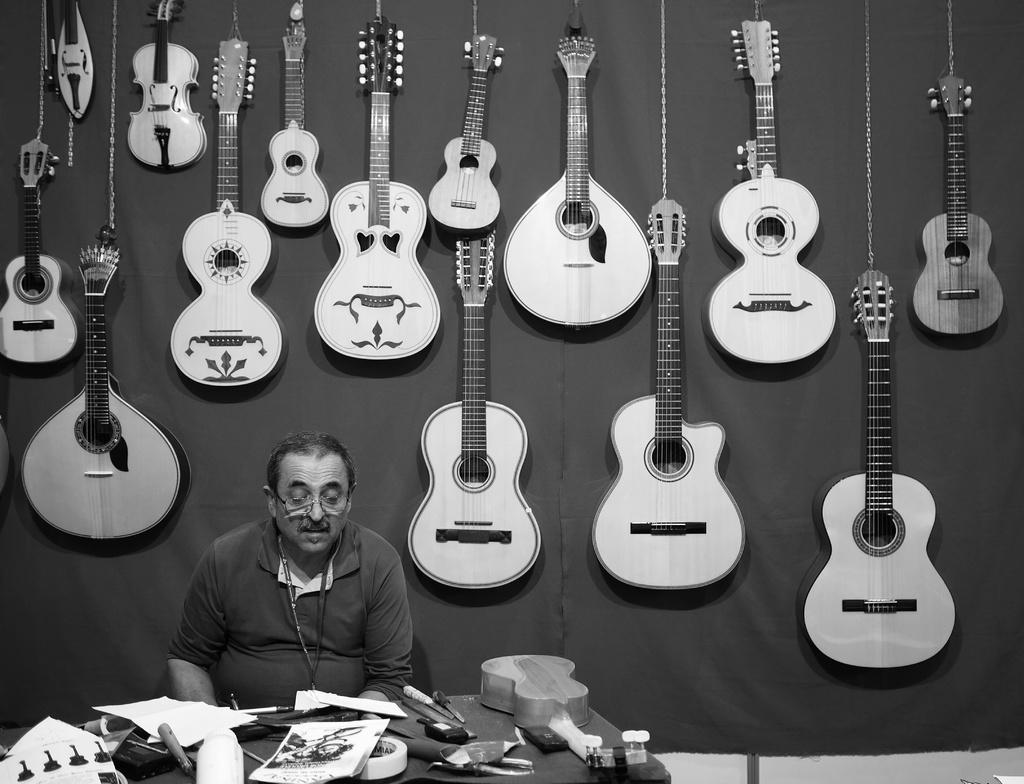Can you describe this image briefly? This person sitting on the chair. We can see musical instrument,poster,papers and things on the table. On the background we can see guitars and musical instruments. 